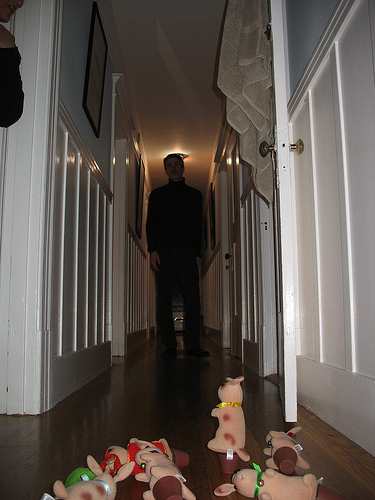<image>
Is the towel next to the man? No. The towel is not positioned next to the man. They are located in different areas of the scene. 